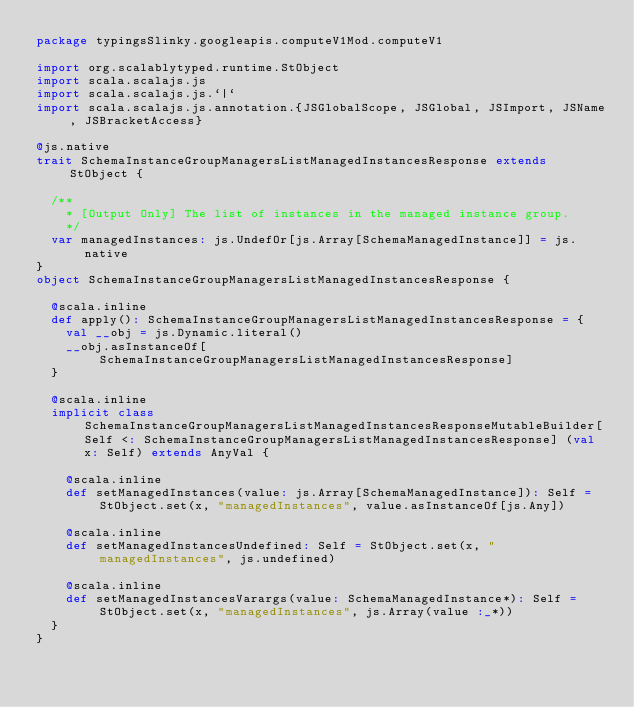<code> <loc_0><loc_0><loc_500><loc_500><_Scala_>package typingsSlinky.googleapis.computeV1Mod.computeV1

import org.scalablytyped.runtime.StObject
import scala.scalajs.js
import scala.scalajs.js.`|`
import scala.scalajs.js.annotation.{JSGlobalScope, JSGlobal, JSImport, JSName, JSBracketAccess}

@js.native
trait SchemaInstanceGroupManagersListManagedInstancesResponse extends StObject {
  
  /**
    * [Output Only] The list of instances in the managed instance group.
    */
  var managedInstances: js.UndefOr[js.Array[SchemaManagedInstance]] = js.native
}
object SchemaInstanceGroupManagersListManagedInstancesResponse {
  
  @scala.inline
  def apply(): SchemaInstanceGroupManagersListManagedInstancesResponse = {
    val __obj = js.Dynamic.literal()
    __obj.asInstanceOf[SchemaInstanceGroupManagersListManagedInstancesResponse]
  }
  
  @scala.inline
  implicit class SchemaInstanceGroupManagersListManagedInstancesResponseMutableBuilder[Self <: SchemaInstanceGroupManagersListManagedInstancesResponse] (val x: Self) extends AnyVal {
    
    @scala.inline
    def setManagedInstances(value: js.Array[SchemaManagedInstance]): Self = StObject.set(x, "managedInstances", value.asInstanceOf[js.Any])
    
    @scala.inline
    def setManagedInstancesUndefined: Self = StObject.set(x, "managedInstances", js.undefined)
    
    @scala.inline
    def setManagedInstancesVarargs(value: SchemaManagedInstance*): Self = StObject.set(x, "managedInstances", js.Array(value :_*))
  }
}
</code> 